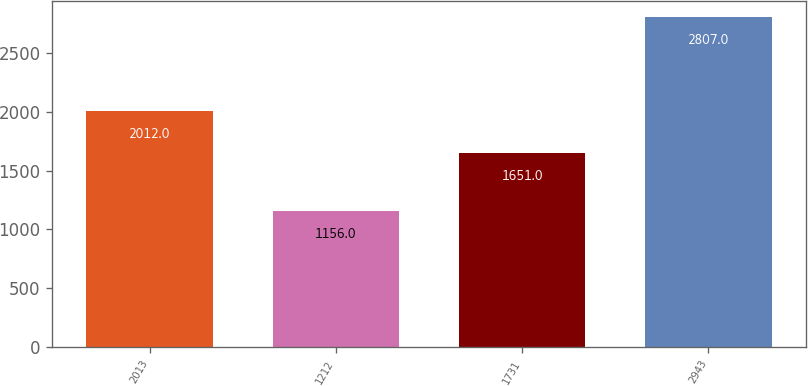<chart> <loc_0><loc_0><loc_500><loc_500><bar_chart><fcel>2013<fcel>1212<fcel>1731<fcel>2943<nl><fcel>2012<fcel>1156<fcel>1651<fcel>2807<nl></chart> 